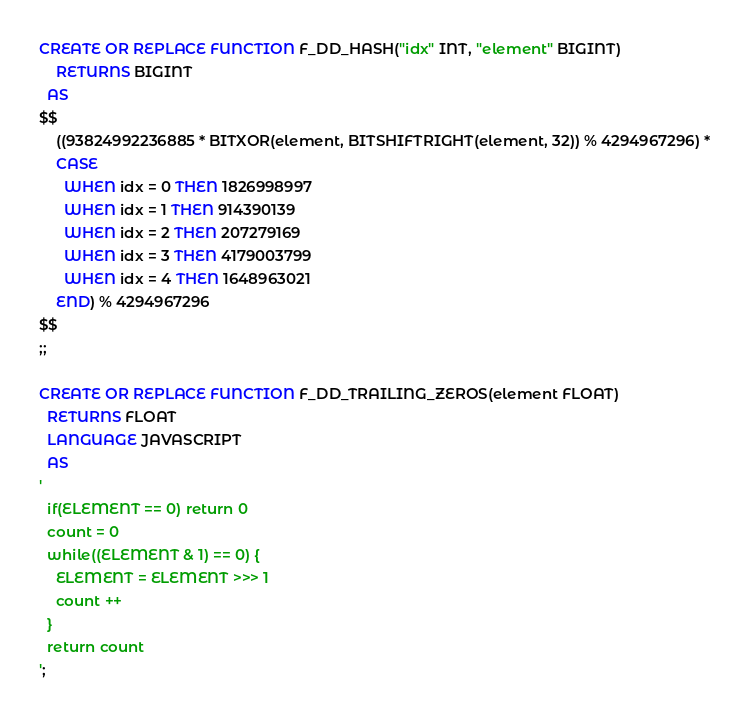Convert code to text. <code><loc_0><loc_0><loc_500><loc_500><_SQL_>CREATE OR REPLACE FUNCTION F_DD_HASH("idx" INT, "element" BIGINT)
	RETURNS BIGINT
  AS 
$$
    ((93824992236885 * BITXOR(element, BITSHIFTRIGHT(element, 32)) % 4294967296) * 
    CASE
      WHEN idx = 0 THEN 1826998997
      WHEN idx = 1 THEN 914390139
      WHEN idx = 2 THEN 207279169
      WHEN idx = 3 THEN 4179003799
      WHEN idx = 4 THEN 1648963021
    END) % 4294967296
$$
;;

CREATE OR REPLACE FUNCTION F_DD_TRAILING_ZEROS(element FLOAT)
  RETURNS FLOAT
  LANGUAGE JAVASCRIPT
  AS 
'
  if(ELEMENT == 0) return 0
  count = 0
  while((ELEMENT & 1) == 0) {
    ELEMENT = ELEMENT >>> 1
    count ++
  }
  return count
';</code> 